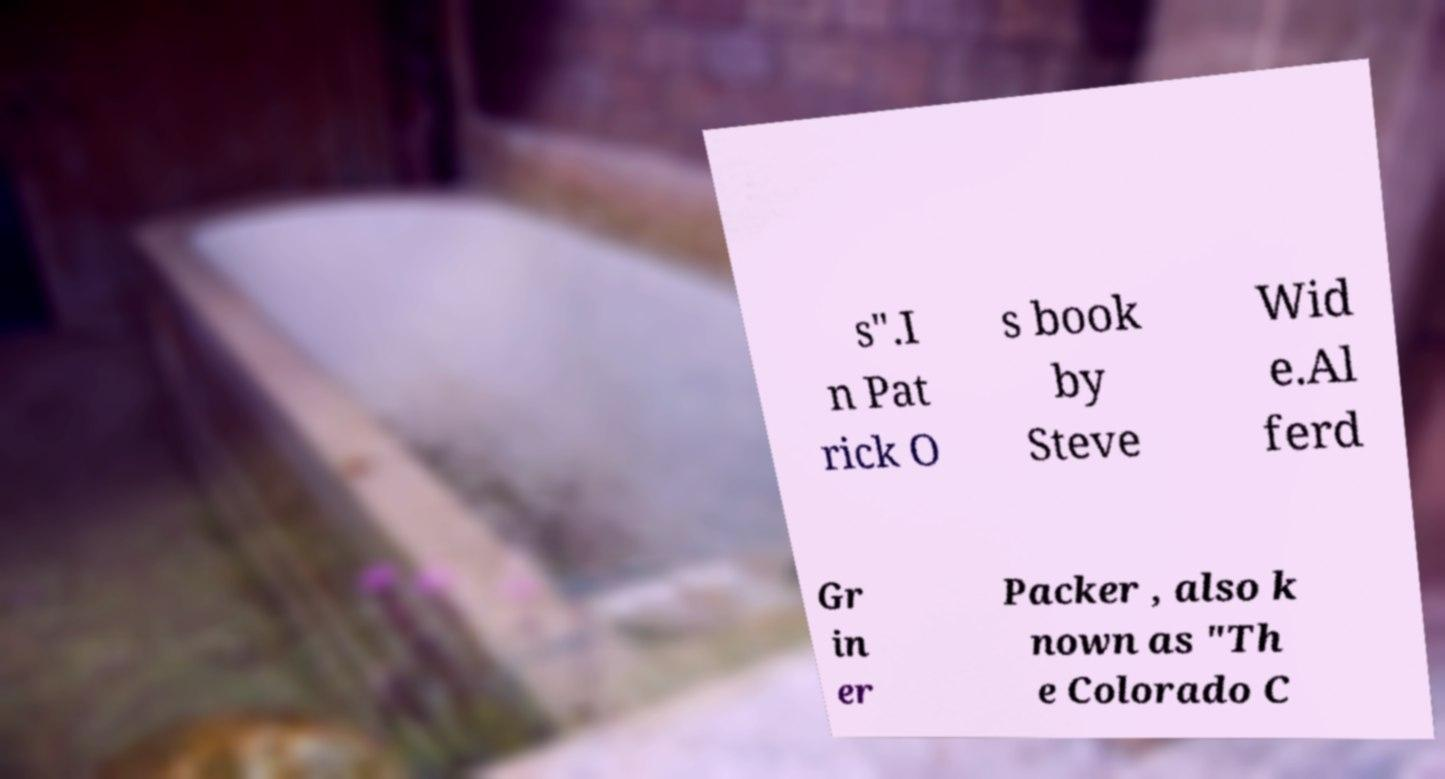Could you assist in decoding the text presented in this image and type it out clearly? s".I n Pat rick O s book by Steve Wid e.Al ferd Gr in er Packer , also k nown as "Th e Colorado C 